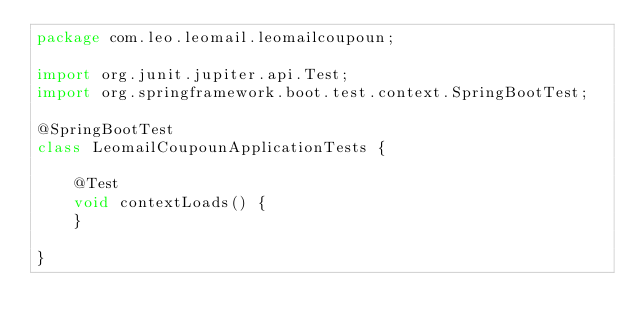<code> <loc_0><loc_0><loc_500><loc_500><_Java_>package com.leo.leomail.leomailcoupoun;

import org.junit.jupiter.api.Test;
import org.springframework.boot.test.context.SpringBootTest;

@SpringBootTest
class LeomailCoupounApplicationTests {

    @Test
    void contextLoads() {
    }

}
</code> 